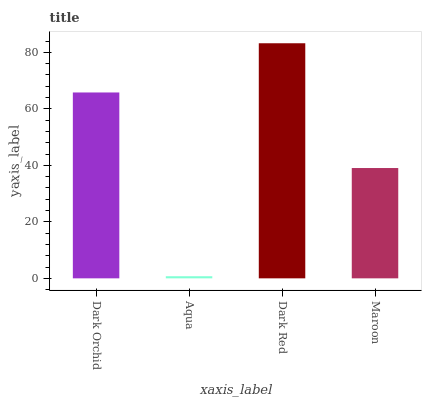Is Dark Red the minimum?
Answer yes or no. No. Is Aqua the maximum?
Answer yes or no. No. Is Dark Red greater than Aqua?
Answer yes or no. Yes. Is Aqua less than Dark Red?
Answer yes or no. Yes. Is Aqua greater than Dark Red?
Answer yes or no. No. Is Dark Red less than Aqua?
Answer yes or no. No. Is Dark Orchid the high median?
Answer yes or no. Yes. Is Maroon the low median?
Answer yes or no. Yes. Is Aqua the high median?
Answer yes or no. No. Is Dark Orchid the low median?
Answer yes or no. No. 